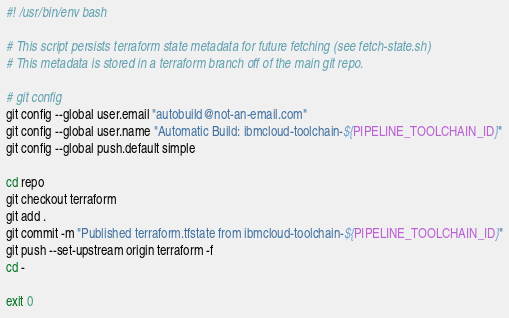Convert code to text. <code><loc_0><loc_0><loc_500><loc_500><_Bash_>#! /usr/bin/env bash

# This script persists terraform state metadata for future fetching (see fetch-state.sh)
# This metadata is stored in a terraform branch off of the main git repo.

# git config
git config --global user.email "autobuild@not-an-email.com"
git config --global user.name "Automatic Build: ibmcloud-toolchain-${PIPELINE_TOOLCHAIN_ID}"
git config --global push.default simple

cd repo
git checkout terraform
git add .
git commit -m "Published terraform.tfstate from ibmcloud-toolchain-${PIPELINE_TOOLCHAIN_ID}"
git push --set-upstream origin terraform -f
cd -

exit 0
</code> 